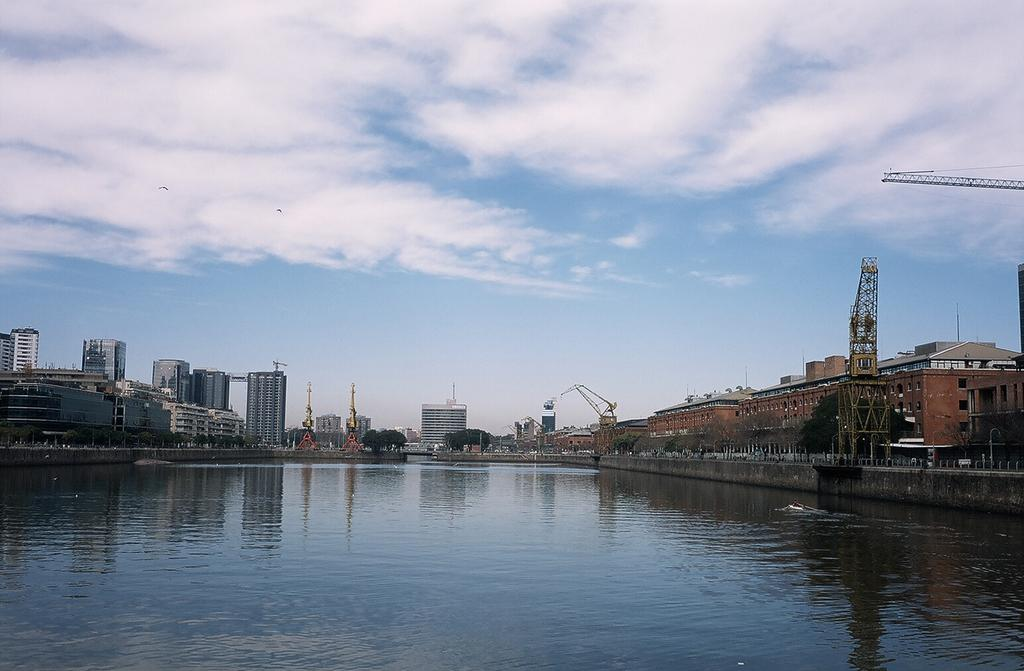What type of natural feature is present in the image? There is a lake in the image. What structures can be seen behind the lake? Buildings are visible behind the lake. What part of the environment is visible in the image? The sky is visible in the image. What can be observed in the sky? Clouds are present in the sky. What type of appliance can be seen in the yard near the lake? There is no appliance present in the image, and the image does not show a yard. 